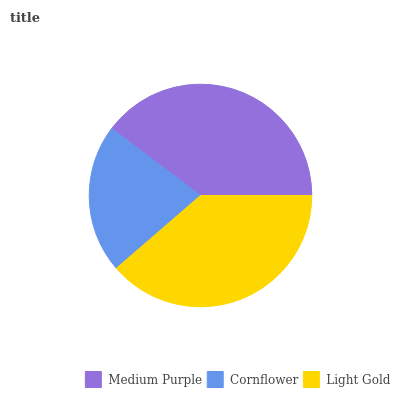Is Cornflower the minimum?
Answer yes or no. Yes. Is Medium Purple the maximum?
Answer yes or no. Yes. Is Light Gold the minimum?
Answer yes or no. No. Is Light Gold the maximum?
Answer yes or no. No. Is Light Gold greater than Cornflower?
Answer yes or no. Yes. Is Cornflower less than Light Gold?
Answer yes or no. Yes. Is Cornflower greater than Light Gold?
Answer yes or no. No. Is Light Gold less than Cornflower?
Answer yes or no. No. Is Light Gold the high median?
Answer yes or no. Yes. Is Light Gold the low median?
Answer yes or no. Yes. Is Medium Purple the high median?
Answer yes or no. No. Is Medium Purple the low median?
Answer yes or no. No. 